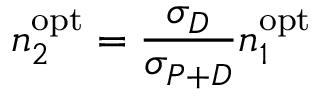Convert formula to latex. <formula><loc_0><loc_0><loc_500><loc_500>n _ { 2 } ^ { o p t } = \frac { \sigma _ { D } } { \sigma _ { P + D } } n _ { 1 } ^ { o p t }</formula> 